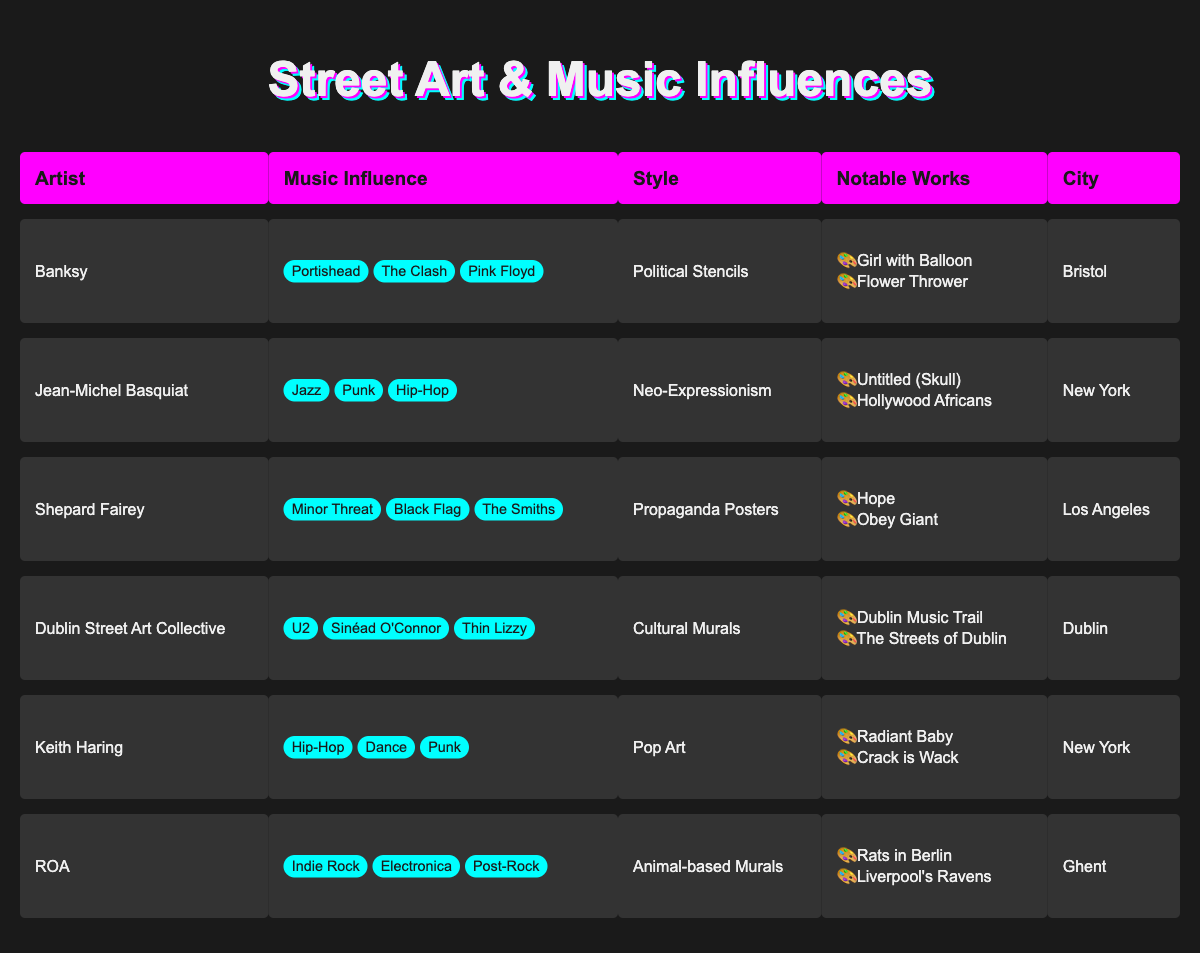What influential music artists inspired Banksy? According to the table, Banksy's music influences are Portishead, The Clash, and Pink Floyd.
Answer: Portishead, The Clash, Pink Floyd Which artist is known for their political stencil style? The table indicates that Banksy is noted for his political stencil style.
Answer: Banksy Is Jean-Michel Basquiat's art influenced by pop music? The table lists his music influences as Jazz, Punk, and Hip-Hop, thus it does not include pop music.
Answer: No What city is associated with the Dublin Street Art Collective? The city listed for the Dublin Street Art Collective in the table is Dublin.
Answer: Dublin How many notable works does ROA have listed in the table? The table shows that ROA has two notable works: "Rats in Berlin" and "Liverpool's Ravens."
Answer: Two Which artist has the most varied music influences and what are they? Shepard Fairey has influences from Minor Threat, Black Flag, and The Smiths, while other artists have fewer influences.
Answer: Shepard Fairey; Minor Threat, Black Flag, The Smiths Which artists have their work categorized as 'Cultural Murals'? The only artist listed with 'Cultural Murals' is the Dublin Street Art Collective in the table.
Answer: Dublin Street Art Collective If you sum the number of notable works for artists based in New York, what would be the total? Keith Haring and Jean-Michel Basquiat, both from New York, have two notable works each. Adding them gives 2 + 2 = 4.
Answer: 4 Does any artist in the table have a music influence that includes both indie and dance music? No, the influences listed do not overlap between indie rock (ROA) and dance (Keith Haring); hence, the answer is no.
Answer: No Which artist is connected to the music influences of U2 and Sinéad O'Connor? The Dublin Street Art Collective is associated with both U2 and Sinéad O'Connor as their music influences.
Answer: Dublin Street Art Collective 